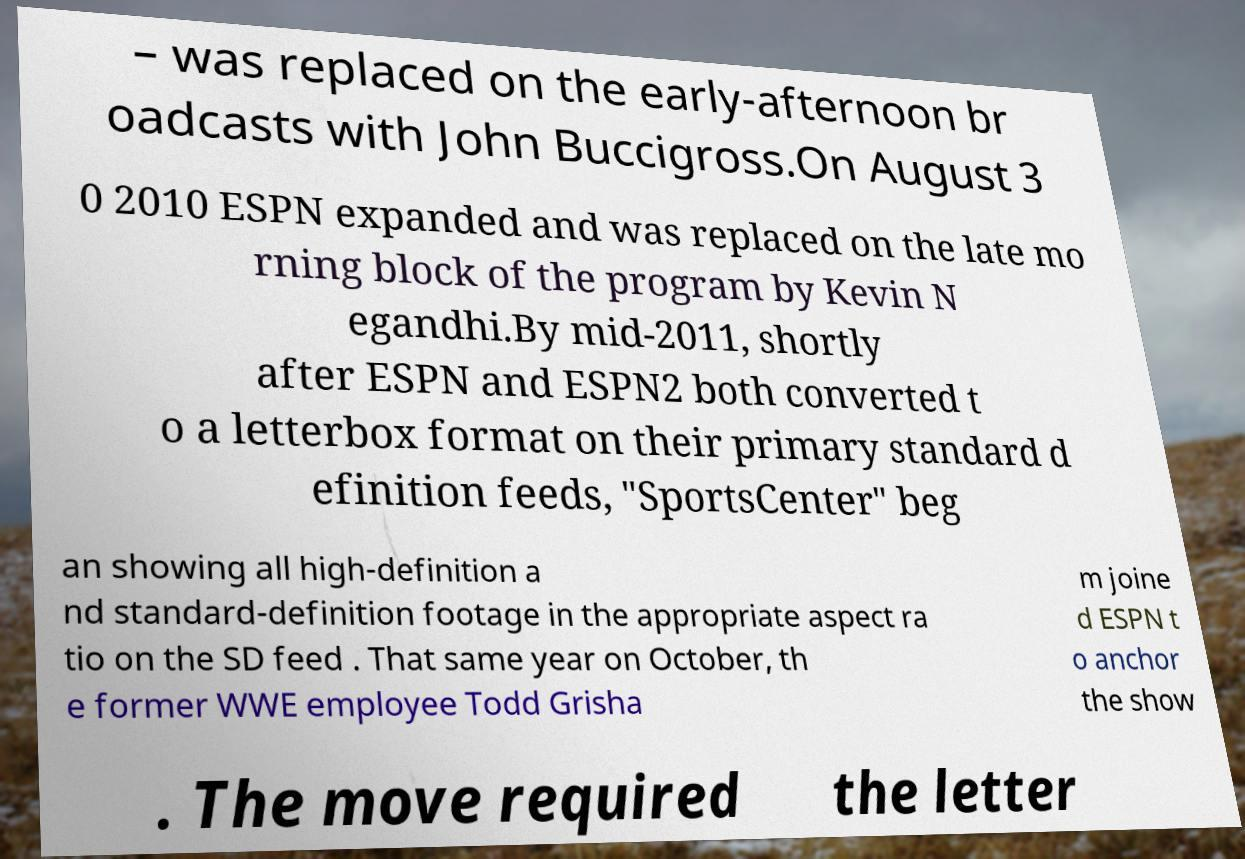Could you extract and type out the text from this image? – was replaced on the early-afternoon br oadcasts with John Buccigross.On August 3 0 2010 ESPN expanded and was replaced on the late mo rning block of the program by Kevin N egandhi.By mid-2011, shortly after ESPN and ESPN2 both converted t o a letterbox format on their primary standard d efinition feeds, "SportsCenter" beg an showing all high-definition a nd standard-definition footage in the appropriate aspect ra tio on the SD feed . That same year on October, th e former WWE employee Todd Grisha m joine d ESPN t o anchor the show . The move required the letter 